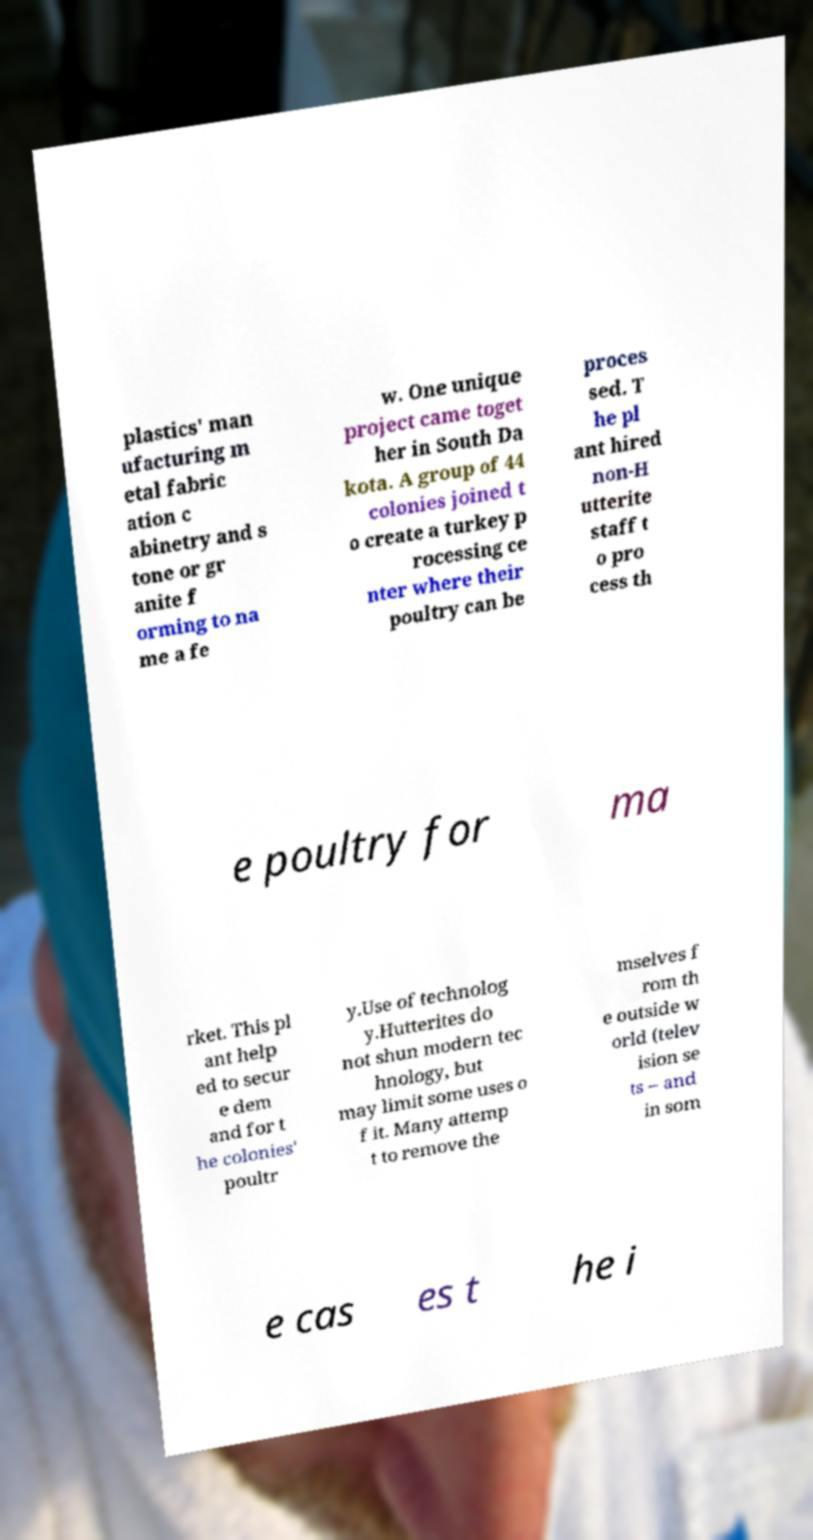Can you accurately transcribe the text from the provided image for me? plastics' man ufacturing m etal fabric ation c abinetry and s tone or gr anite f orming to na me a fe w. One unique project came toget her in South Da kota. A group of 44 colonies joined t o create a turkey p rocessing ce nter where their poultry can be proces sed. T he pl ant hired non-H utterite staff t o pro cess th e poultry for ma rket. This pl ant help ed to secur e dem and for t he colonies' poultr y.Use of technolog y.Hutterites do not shun modern tec hnology, but may limit some uses o f it. Many attemp t to remove the mselves f rom th e outside w orld (telev ision se ts – and in som e cas es t he i 